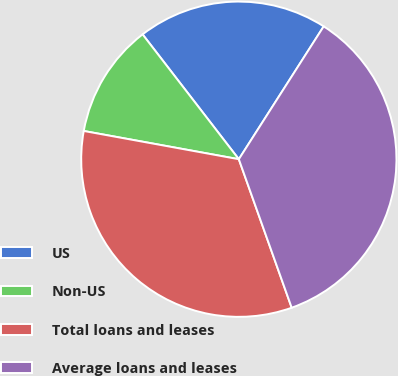Convert chart to OTSL. <chart><loc_0><loc_0><loc_500><loc_500><pie_chart><fcel>US<fcel>Non-US<fcel>Total loans and leases<fcel>Average loans and leases<nl><fcel>19.5%<fcel>11.68%<fcel>33.31%<fcel>35.51%<nl></chart> 